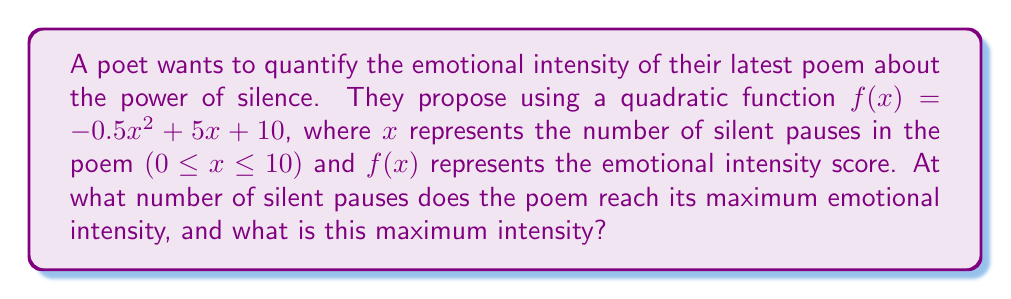Give your solution to this math problem. 1) The quadratic function given is $f(x) = -0.5x^2 + 5x + 10$

2) For a quadratic function in the form $f(x) = ax^2 + bx + c$, the x-coordinate of the vertex (which gives the maximum or minimum point) is given by $x = -\frac{b}{2a}$

3) In this case, $a = -0.5$ and $b = 5$

4) Substituting these values:
   $x = -\frac{5}{2(-0.5)} = -\frac{5}{-1} = 5$

5) This means the maximum emotional intensity occurs when there are 5 silent pauses

6) To find the maximum intensity, we substitute $x = 5$ into the original function:

   $f(5) = -0.5(5)^2 + 5(5) + 10$
   $    = -0.5(25) + 25 + 10$
   $    = -12.5 + 25 + 10$
   $    = 22.5$

Therefore, the maximum emotional intensity is 22.5, occurring at 5 silent pauses.
Answer: 5 pauses; 22.5 intensity 